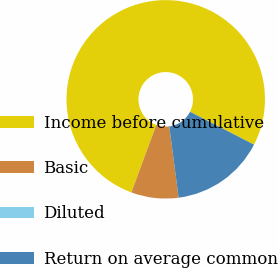<chart> <loc_0><loc_0><loc_500><loc_500><pie_chart><fcel>Income before cumulative<fcel>Basic<fcel>Diluted<fcel>Return on average common<nl><fcel>76.92%<fcel>7.69%<fcel>0.0%<fcel>15.38%<nl></chart> 